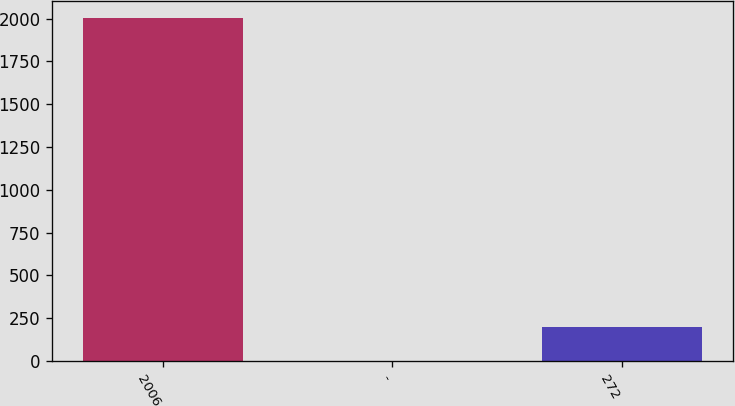Convert chart to OTSL. <chart><loc_0><loc_0><loc_500><loc_500><bar_chart><fcel>2006<fcel>-<fcel>272<nl><fcel>2004<fcel>0.4<fcel>200.76<nl></chart> 